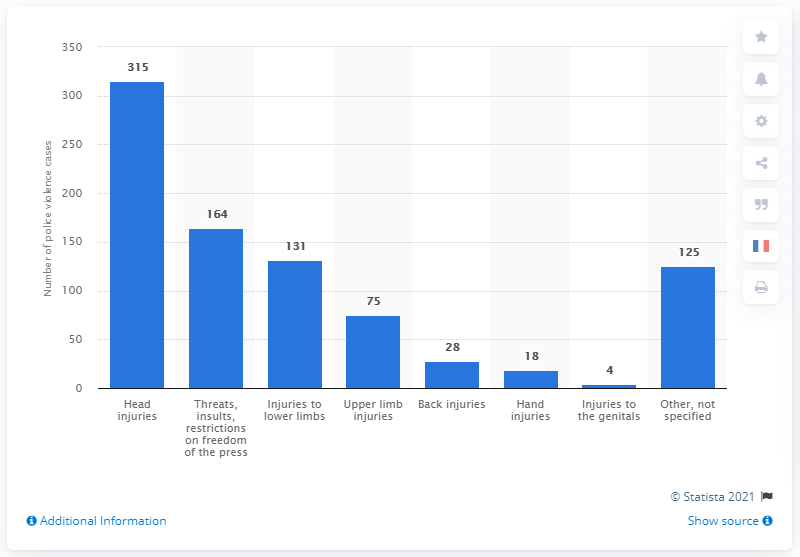Highlight a few significant elements in this photo. As of the beginning of the "yellow vests" movement, a total of 315 head injuries have been reported. During the "yellow vests" movement, a total of 164 cases of threats, insults, or restrictions on freedom of the press were recorded. 